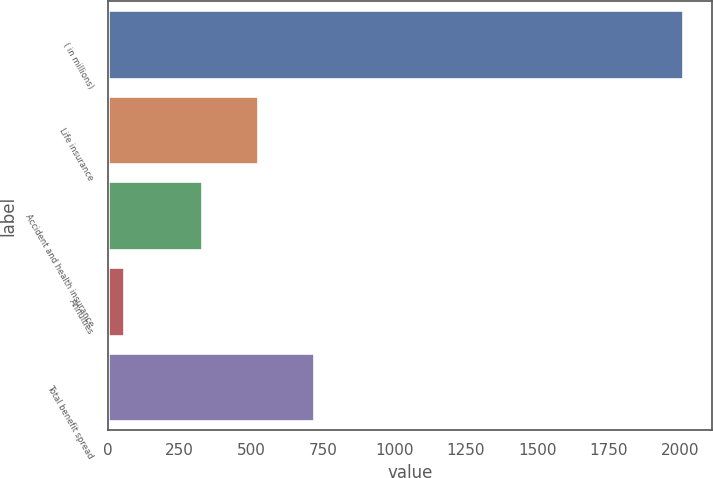<chart> <loc_0><loc_0><loc_500><loc_500><bar_chart><fcel>( in millions)<fcel>Life insurance<fcel>Accident and health insurance<fcel>Annuities<fcel>Total benefit spread<nl><fcel>2011<fcel>524.6<fcel>329<fcel>55<fcel>720.2<nl></chart> 